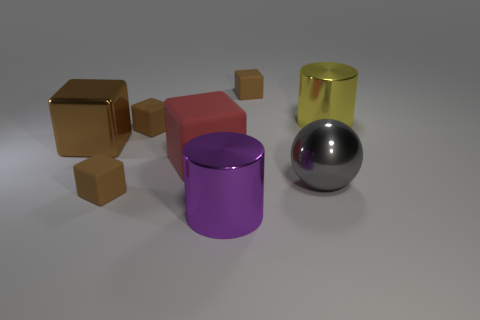Subtract all brown spheres. How many brown cubes are left? 4 Subtract all red blocks. How many blocks are left? 4 Subtract all large metallic blocks. How many blocks are left? 4 Subtract all green cubes. Subtract all cyan cylinders. How many cubes are left? 5 Add 1 big blue matte objects. How many objects exist? 9 Subtract all cylinders. How many objects are left? 6 Subtract 1 gray balls. How many objects are left? 7 Subtract all large metal balls. Subtract all brown rubber objects. How many objects are left? 4 Add 8 metal spheres. How many metal spheres are left? 9 Add 4 purple metal cylinders. How many purple metal cylinders exist? 5 